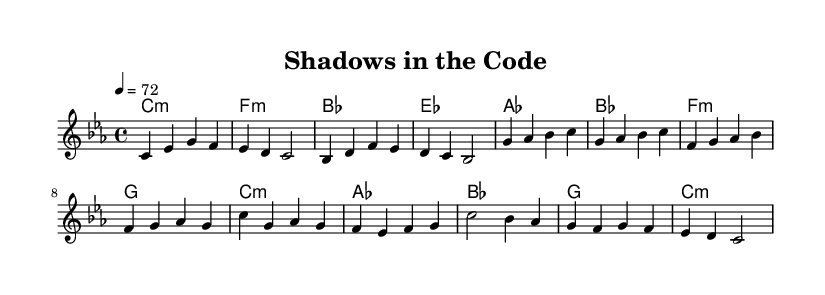What is the key signature of this music? The key signature is indicated by the initial clef and shows a minor key, which is C minor. It contains three flats.
Answer: C minor What is the time signature of this music? The time signature is displayed at the beginning of the staff and shows that there are four beats per measure with a quarter note getting the beat, indicating a 4/4 time signature.
Answer: 4/4 What is the tempo marking for this piece? The tempo can be found above the staff written as a metronome marking of 72 beats per minute.
Answer: 72 How many measures are in the verse section? By analyzing the melody section, there are four measures in the verse, as each segment separated by vertical lines indicates a measure.
Answer: 4 What is the chord progression of the chorus? The chord progression for the chorus can be gathered from the harmonies section, where the chords for measures are listed as C minor, A flat, B flat, G, and C minor.
Answer: C minor, A flat, B flat, G, C minor What theme does this ballad explore? The title "Shadows in the Code" and the context suggest the song explores themes of secrecy and double lives, indicative of contemporary pop ballads focusing on hidden aspects and duality in relationships.
Answer: Secrecy and double lives 